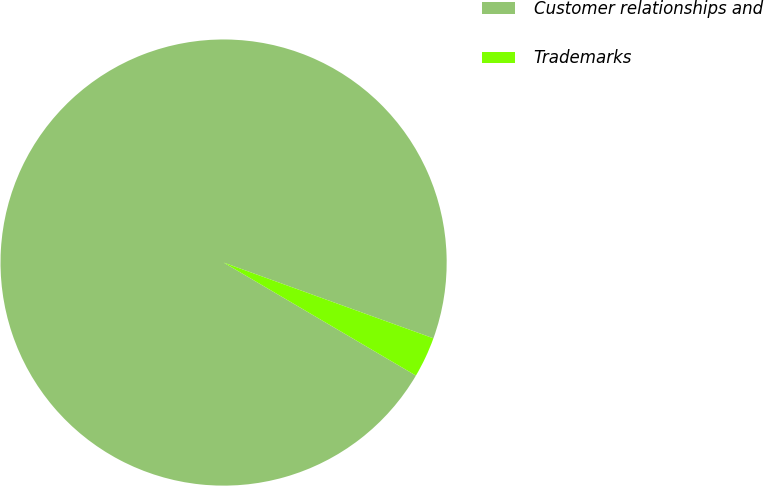Convert chart to OTSL. <chart><loc_0><loc_0><loc_500><loc_500><pie_chart><fcel>Customer relationships and<fcel>Trademarks<nl><fcel>97.06%<fcel>2.94%<nl></chart> 